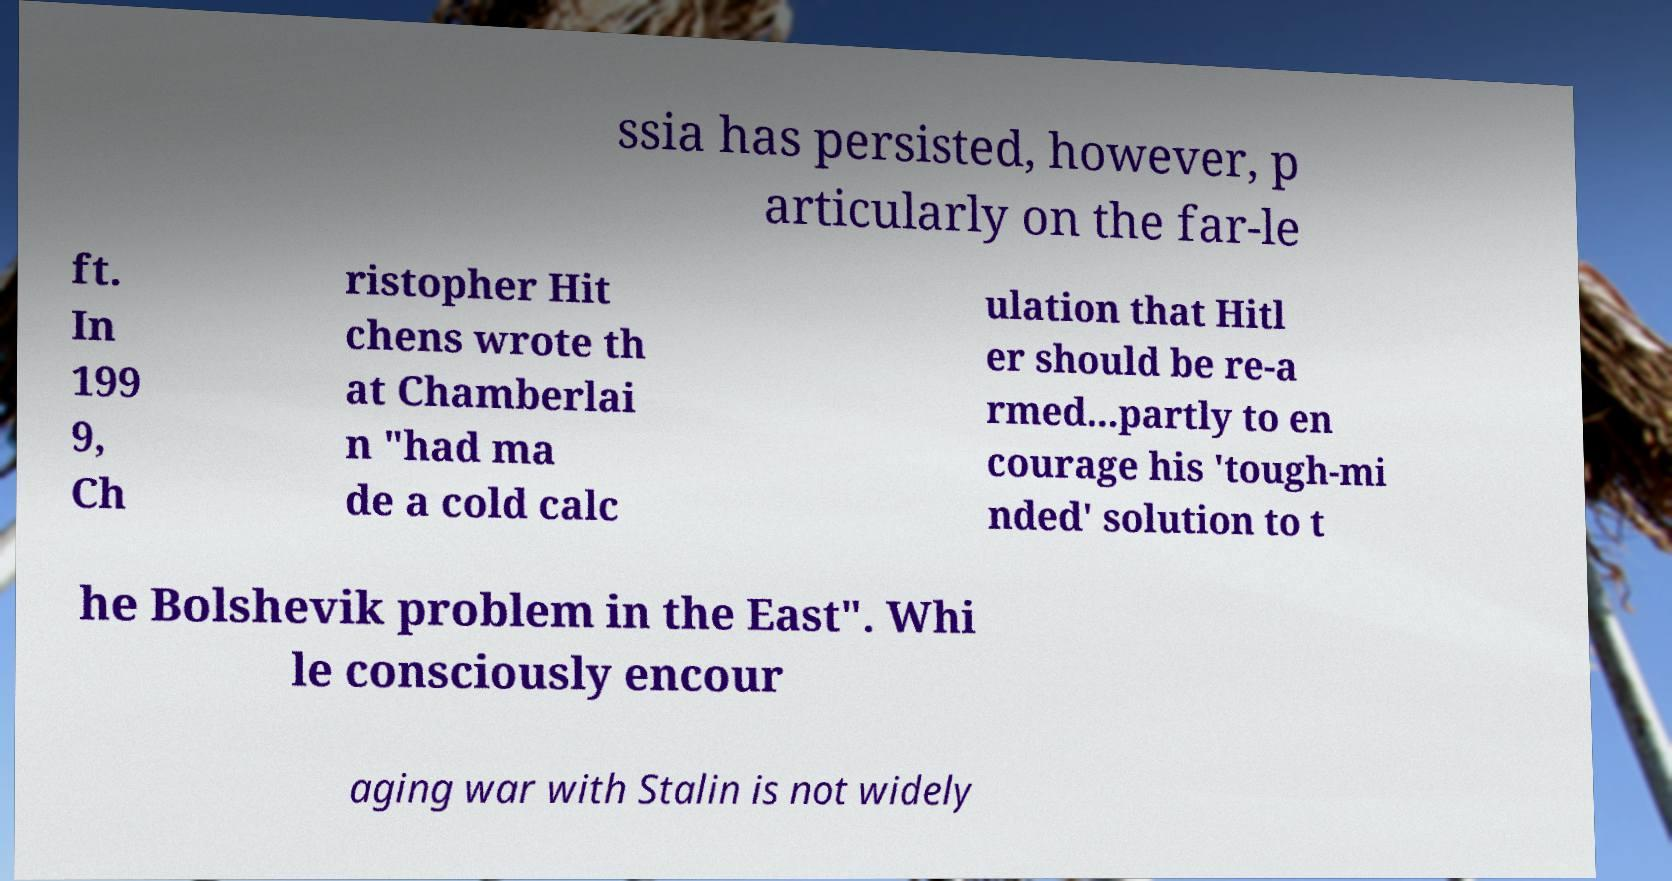Could you assist in decoding the text presented in this image and type it out clearly? ssia has persisted, however, p articularly on the far-le ft. In 199 9, Ch ristopher Hit chens wrote th at Chamberlai n "had ma de a cold calc ulation that Hitl er should be re-a rmed...partly to en courage his 'tough-mi nded' solution to t he Bolshevik problem in the East". Whi le consciously encour aging war with Stalin is not widely 